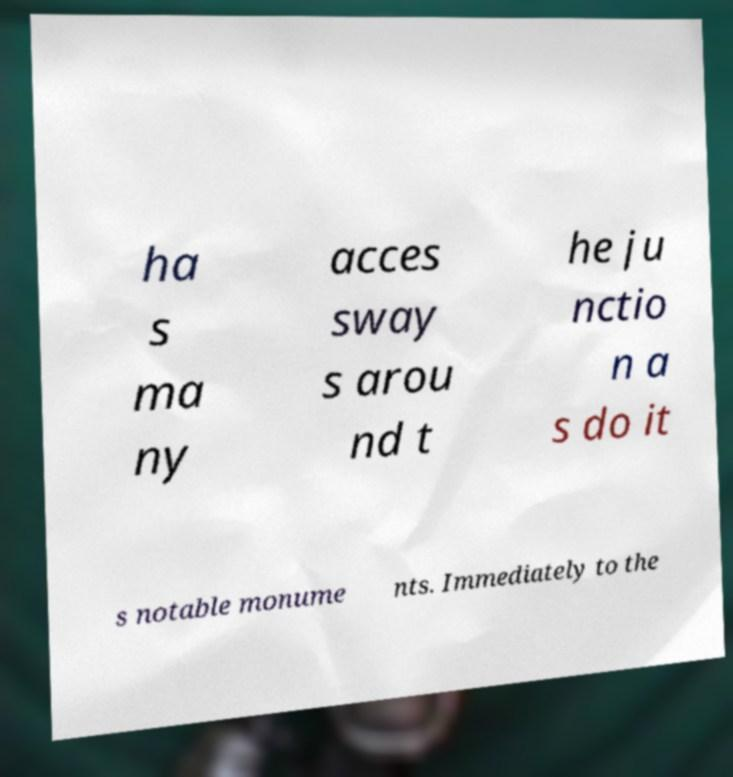Can you accurately transcribe the text from the provided image for me? ha s ma ny acces sway s arou nd t he ju nctio n a s do it s notable monume nts. Immediately to the 